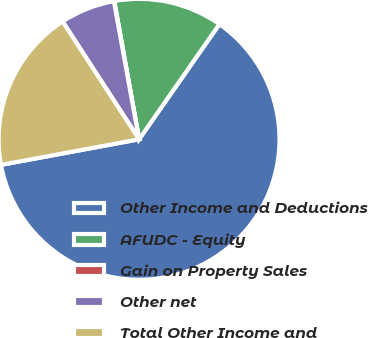<chart> <loc_0><loc_0><loc_500><loc_500><pie_chart><fcel>Other Income and Deductions<fcel>AFUDC - Equity<fcel>Gain on Property Sales<fcel>Other net<fcel>Total Other Income and<nl><fcel>62.39%<fcel>12.52%<fcel>0.05%<fcel>6.29%<fcel>18.75%<nl></chart> 